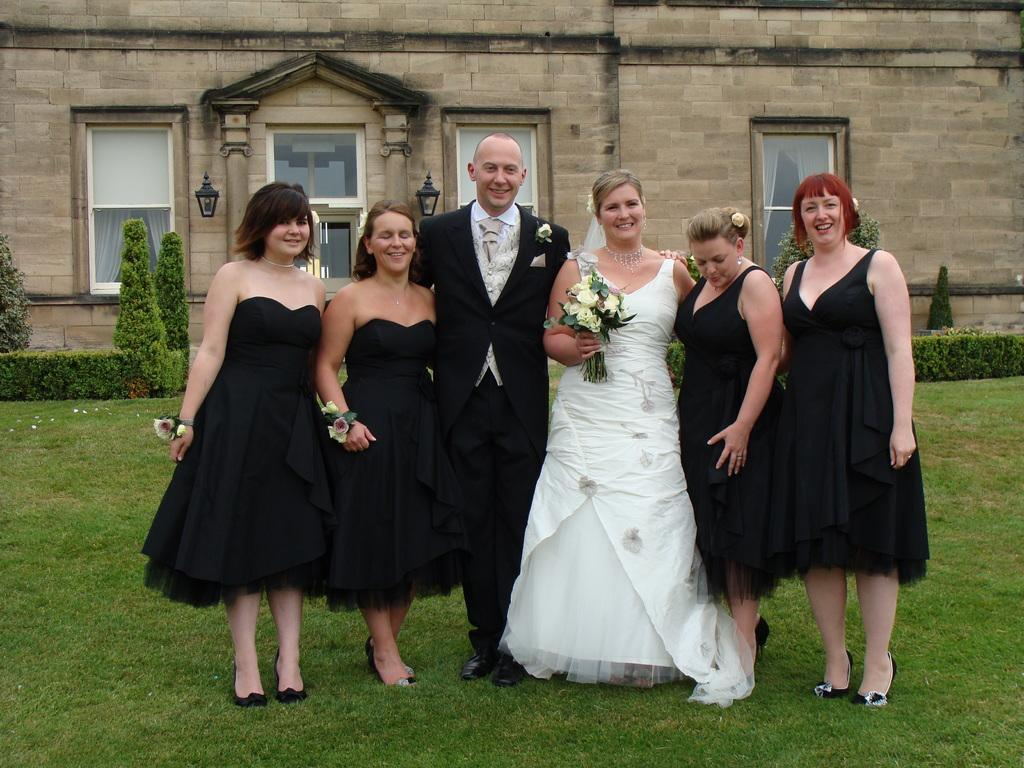What are the people in the image doing? The people in the image are standing on the ground. What can be seen in the background of the image? There are plants and a building in the background of the image. What features does the building have? The building has windows and a door. How many minutes does it take for the hammer to fall in the image? There is no hammer present in the image, so it is not possible to determine how long it would take for it to fall. 